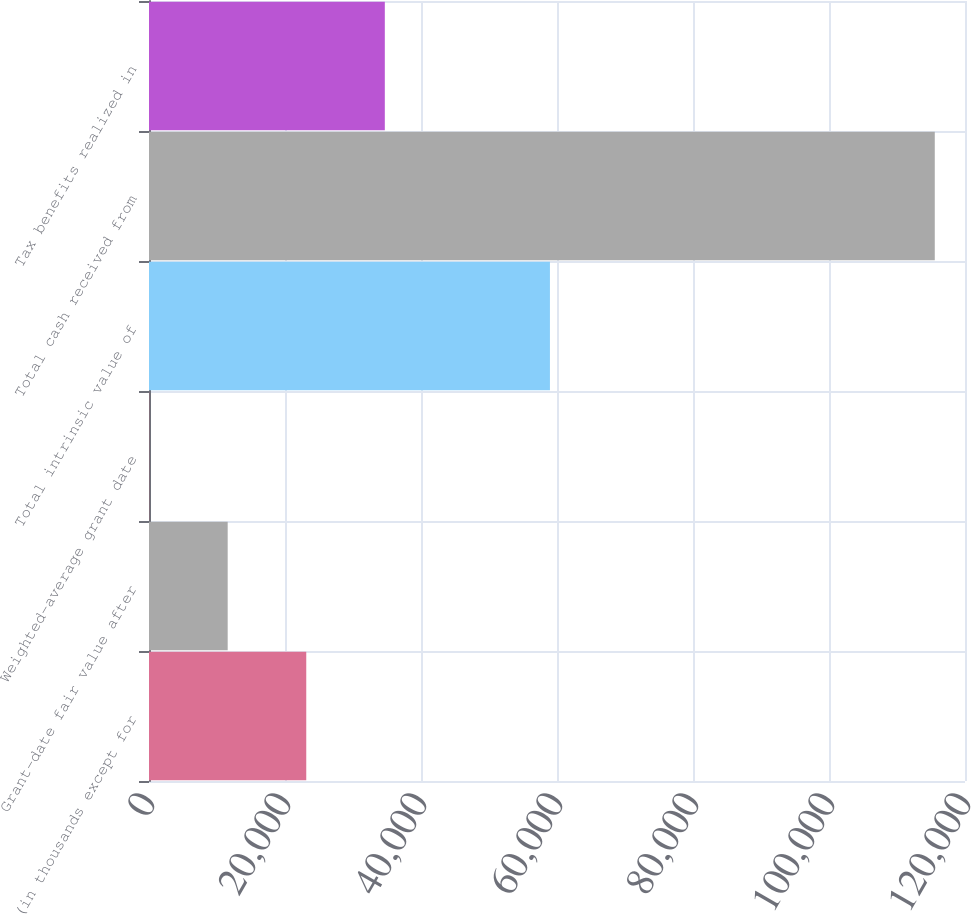Convert chart. <chart><loc_0><loc_0><loc_500><loc_500><bar_chart><fcel>(in thousands except for<fcel>Grant-date fair value after<fcel>Weighted-average grant date<fcel>Total intrinsic value of<fcel>Total cash received from<fcel>Tax benefits realized in<nl><fcel>23125.6<fcel>11571.8<fcel>17.95<fcel>58960<fcel>115556<fcel>34679.4<nl></chart> 